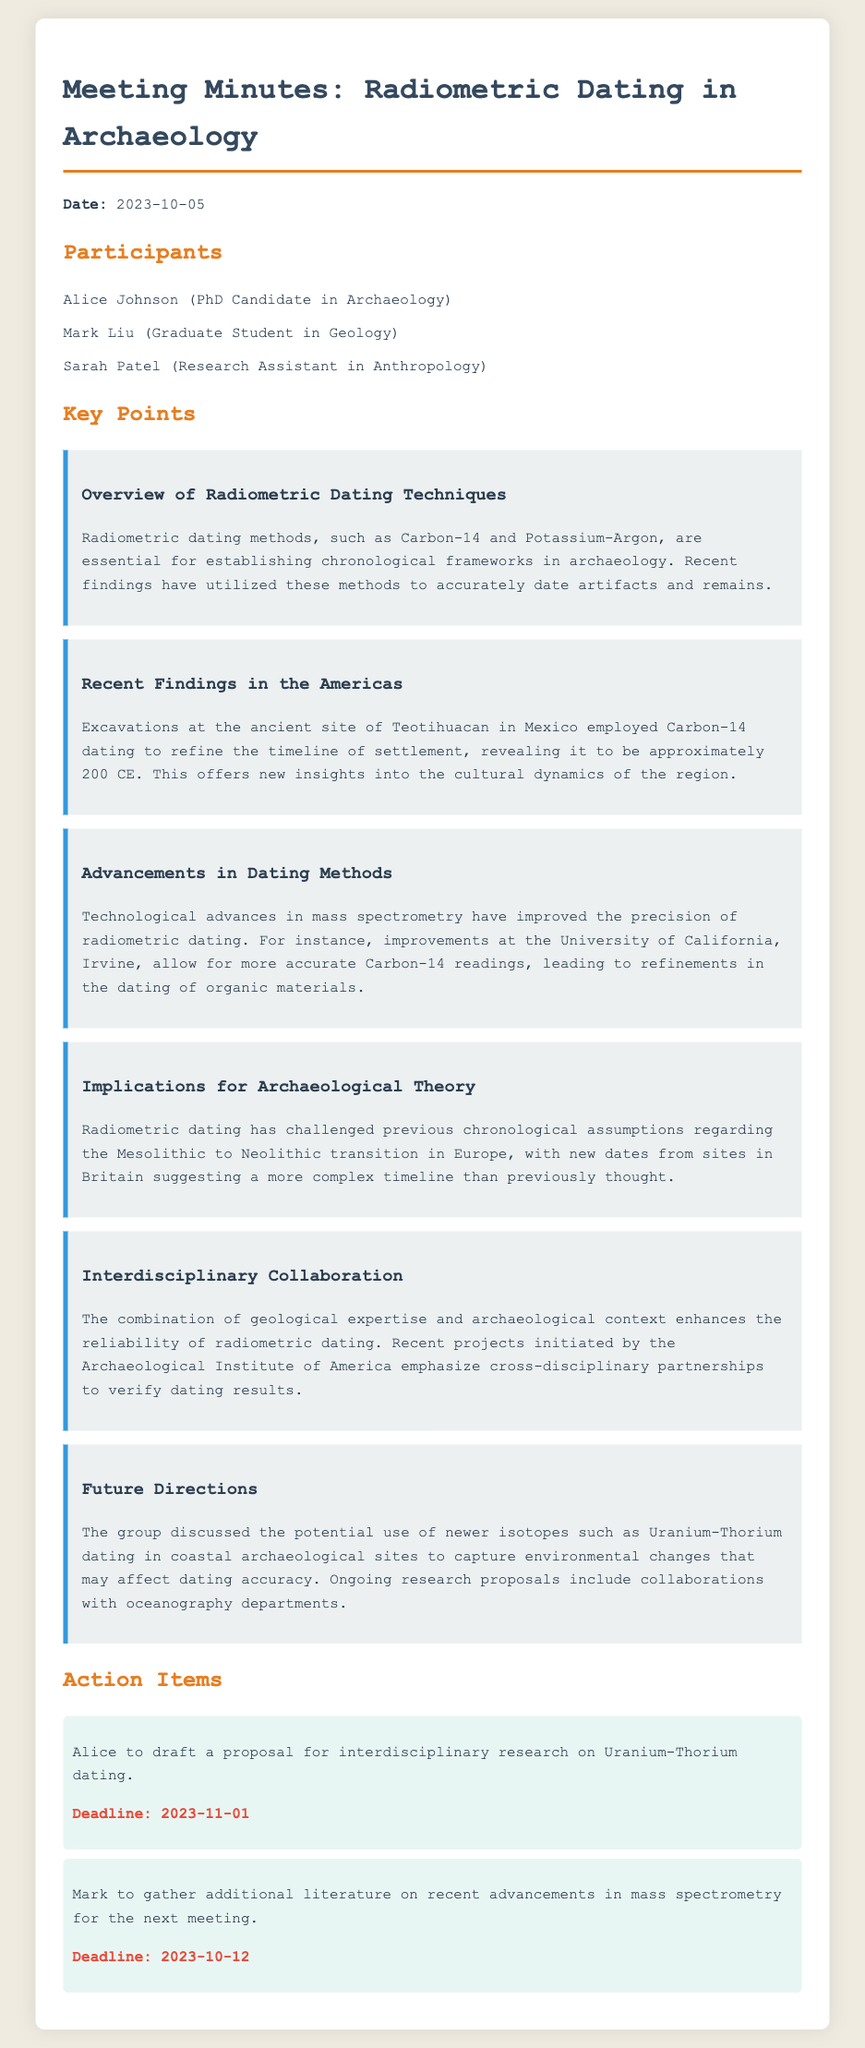What is the date of the meeting? The date of the meeting is explicitly mentioned at the beginning of the document.
Answer: 2023-10-05 Who is the PhD candidate in Archaeology? The document lists participants, including their roles, names, and fields of study.
Answer: Alice Johnson What radiometric dating method was used at Teotihuacan? The key points mention specific dating methods applied in recent findings at various sites.
Answer: Carbon-14 What significant finding was revealed about Teotihuacan? The document highlights the implications of recent archaeological findings related to temporal accuracy.
Answer: Approximately 200 CE What technology has improved the precision of radiometric dating? The advancements discussed in the document refer to specific technologies that enhance dating accuracy.
Answer: Mass spectrometry What is Alice's action item related to? The action items outline specific tasks assigned to participants, including their content and deadlines.
Answer: Interdisciplinary research on Uranium-Thorium dating When is the deadline for Mark's task? Each action item has an associated deadline that is clearly stated in the document.
Answer: 2023-10-12 How does radiometric dating impact archaeological theory? The document discusses broader implications and challenges to existing theories based on new findings.
Answer: Challenges previous chronological assumptions What interdisciplinary organization is mentioned in the document? The document references specific initiatives that promote collaboration across fields related to archaeology.
Answer: Archaeological Institute of America 